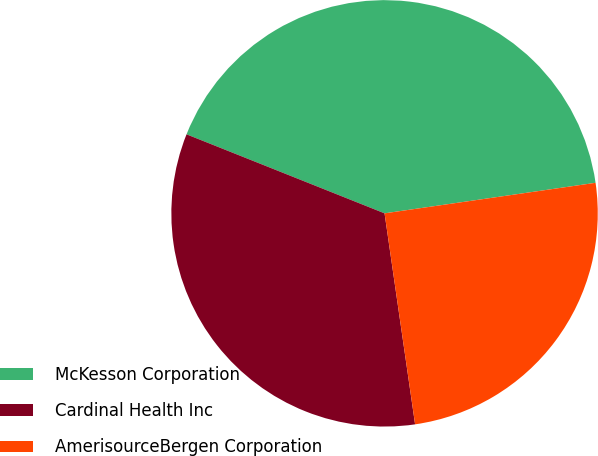<chart> <loc_0><loc_0><loc_500><loc_500><pie_chart><fcel>McKesson Corporation<fcel>Cardinal Health Inc<fcel>AmerisourceBergen Corporation<nl><fcel>41.67%<fcel>33.33%<fcel>25.0%<nl></chart> 